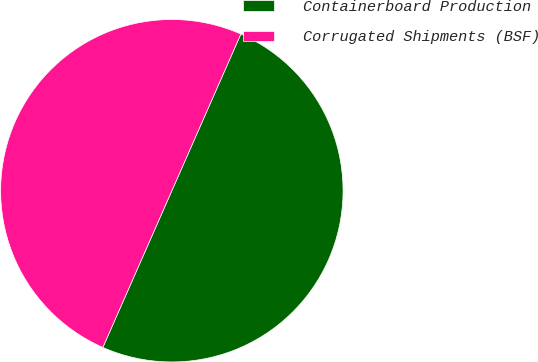Convert chart to OTSL. <chart><loc_0><loc_0><loc_500><loc_500><pie_chart><fcel>Containerboard Production<fcel>Corrugated Shipments (BSF)<nl><fcel>50.0%<fcel>50.0%<nl></chart> 